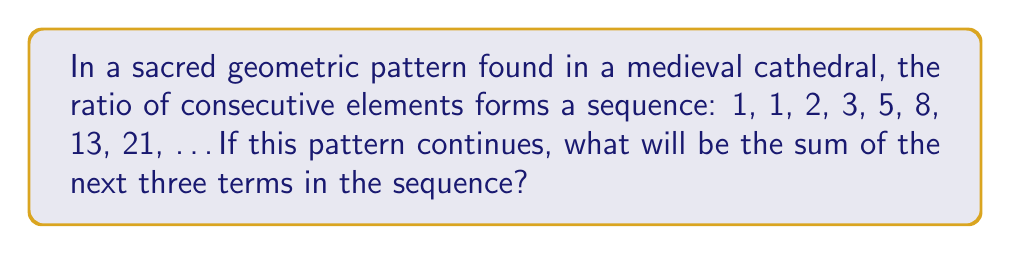What is the answer to this math problem? To solve this problem, let's follow these steps:

1) First, we need to recognize the sequence. This is the famous Fibonacci sequence, where each number is the sum of the two preceding ones. It's often found in religious art and architecture due to its perceived divine properties.

2) We're given the sequence up to 21. Let's calculate the next three terms:
   
   $F_9 = F_8 + F_7 = 21 + 13 = 34$
   $F_{10} = F_9 + F_8 = 34 + 21 = 55$
   $F_{11} = F_{10} + F_9 = 55 + 34 = 89$

3) Now that we have the next three terms (34, 55, 89), we need to sum them:

   $34 + 55 + 89 = 178$

Therefore, the sum of the next three terms in the sequence is 178.

This sum reflects the growth and harmony often represented in religious symbolism, as the Fibonacci sequence is closely related to the Golden Ratio ($\phi = \frac{1+\sqrt{5}}{2}$), which is frequently used in religious art and architecture for its aesthetic appeal and symbolic significance.
Answer: 178 